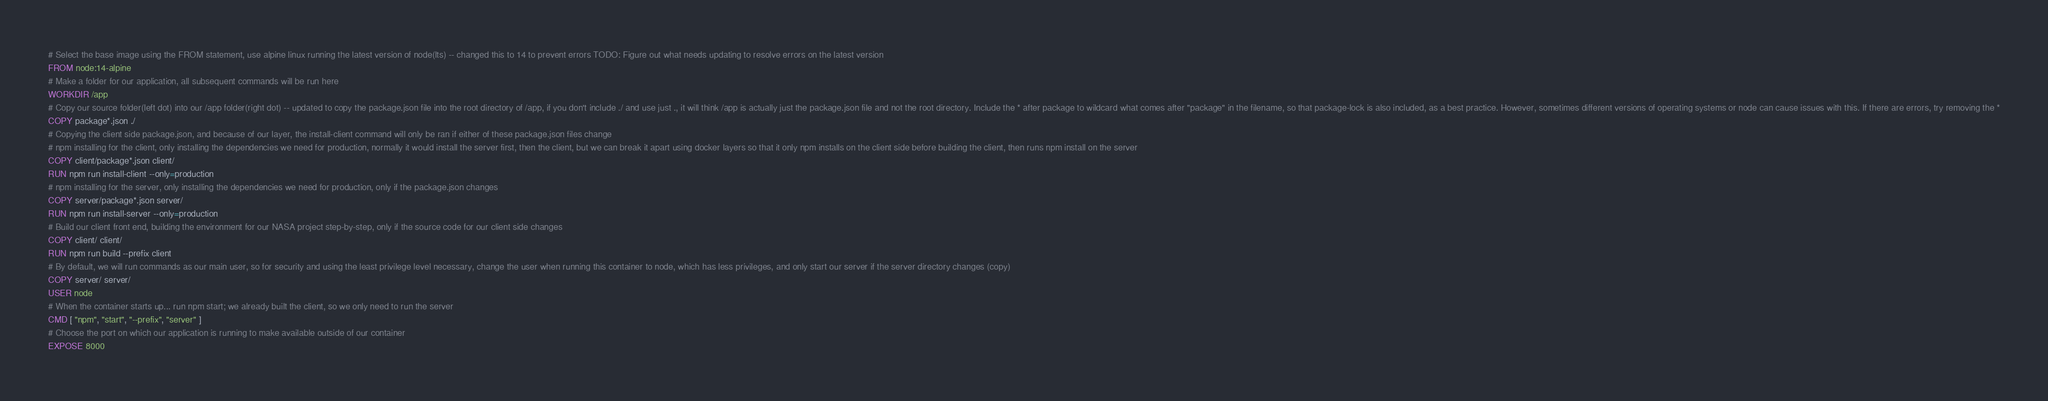<code> <loc_0><loc_0><loc_500><loc_500><_Dockerfile_># Select the base image using the FROM statement, use alpine linux running the latest version of node(lts) -- changed this to 14 to prevent errors TODO: Figure out what needs updating to resolve errors on the latest version
FROM node:14-alpine
# Make a folder for our application, all subsequent commands will be run here
WORKDIR /app
# Copy our source folder(left dot) into our /app folder(right dot) -- updated to copy the package.json file into the root directory of /app, if you don't include ./ and use just ., it will think /app is actually just the package.json file and not the root directory. Include the * after package to wildcard what comes after "package" in the filename, so that package-lock is also included, as a best practice. However, sometimes different versions of operating systems or node can cause issues with this. If there are errors, try removing the *
COPY package*.json ./
# Copying the client side package.json, and because of our layer, the install-client command will only be ran if either of these package.json files change
# npm installing for the client, only installing the dependencies we need for production, normally it would install the server first, then the client, but we can break it apart using docker layers so that it only npm installs on the client side before building the client, then runs npm install on the server
COPY client/package*.json client/
RUN npm run install-client --only=production
# npm installing for the server, only installing the dependencies we need for production, only if the package.json changes
COPY server/package*.json server/
RUN npm run install-server --only=production
# Build our client front end, building the environment for our NASA project step-by-step, only if the source code for our client side changes
COPY client/ client/
RUN npm run build --prefix client
# By default, we will run commands as our main user, so for security and using the least privilege level necessary, change the user when running this container to node, which has less privileges, and only start our server if the server directory changes (copy)
COPY server/ server/
USER node
# When the container starts up... run npm start; we already built the client, so we only need to run the server
CMD [ "npm", "start", "--prefix", "server" ]
# Choose the port on which our application is running to make available outside of our container
EXPOSE 8000</code> 